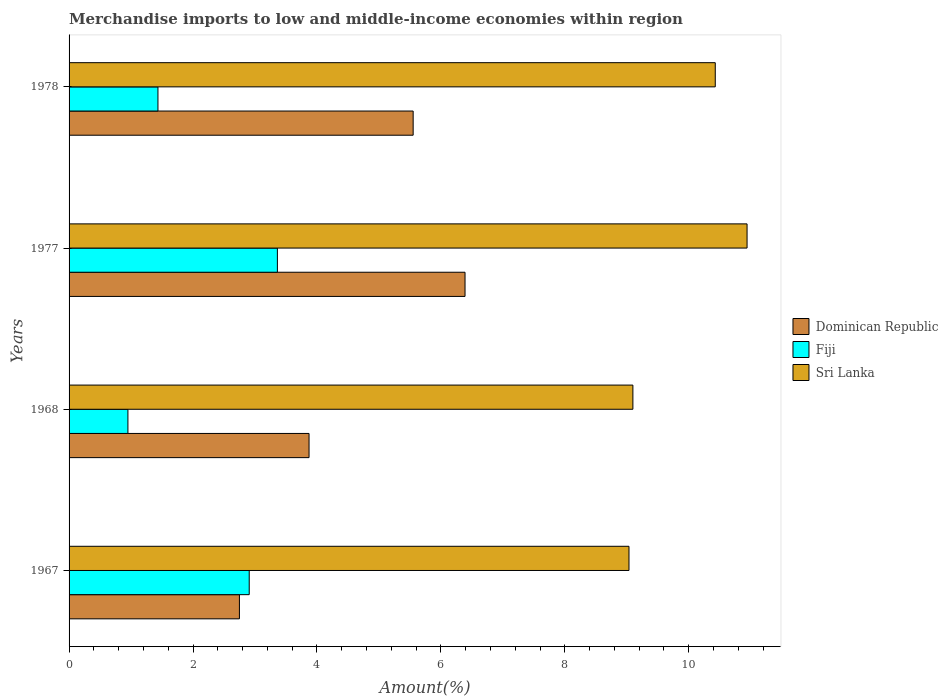How many different coloured bars are there?
Give a very brief answer. 3. How many groups of bars are there?
Your answer should be very brief. 4. How many bars are there on the 4th tick from the top?
Your response must be concise. 3. What is the label of the 1st group of bars from the top?
Offer a very short reply. 1978. What is the percentage of amount earned from merchandise imports in Dominican Republic in 1977?
Your answer should be very brief. 6.39. Across all years, what is the maximum percentage of amount earned from merchandise imports in Sri Lanka?
Offer a very short reply. 10.94. Across all years, what is the minimum percentage of amount earned from merchandise imports in Sri Lanka?
Provide a short and direct response. 9.04. In which year was the percentage of amount earned from merchandise imports in Sri Lanka maximum?
Ensure brevity in your answer.  1977. In which year was the percentage of amount earned from merchandise imports in Sri Lanka minimum?
Offer a very short reply. 1967. What is the total percentage of amount earned from merchandise imports in Sri Lanka in the graph?
Provide a succinct answer. 39.5. What is the difference between the percentage of amount earned from merchandise imports in Sri Lanka in 1967 and that in 1977?
Provide a succinct answer. -1.91. What is the difference between the percentage of amount earned from merchandise imports in Sri Lanka in 1977 and the percentage of amount earned from merchandise imports in Dominican Republic in 1968?
Ensure brevity in your answer.  7.07. What is the average percentage of amount earned from merchandise imports in Sri Lanka per year?
Your response must be concise. 9.88. In the year 1968, what is the difference between the percentage of amount earned from merchandise imports in Sri Lanka and percentage of amount earned from merchandise imports in Dominican Republic?
Your response must be concise. 5.23. What is the ratio of the percentage of amount earned from merchandise imports in Sri Lanka in 1968 to that in 1977?
Your answer should be very brief. 0.83. Is the percentage of amount earned from merchandise imports in Sri Lanka in 1977 less than that in 1978?
Provide a succinct answer. No. Is the difference between the percentage of amount earned from merchandise imports in Sri Lanka in 1968 and 1978 greater than the difference between the percentage of amount earned from merchandise imports in Dominican Republic in 1968 and 1978?
Give a very brief answer. Yes. What is the difference between the highest and the second highest percentage of amount earned from merchandise imports in Sri Lanka?
Give a very brief answer. 0.51. What is the difference between the highest and the lowest percentage of amount earned from merchandise imports in Fiji?
Offer a terse response. 2.41. In how many years, is the percentage of amount earned from merchandise imports in Sri Lanka greater than the average percentage of amount earned from merchandise imports in Sri Lanka taken over all years?
Make the answer very short. 2. What does the 1st bar from the top in 1967 represents?
Ensure brevity in your answer.  Sri Lanka. What does the 2nd bar from the bottom in 1977 represents?
Provide a succinct answer. Fiji. How many bars are there?
Your response must be concise. 12. Are all the bars in the graph horizontal?
Provide a succinct answer. Yes. Does the graph contain any zero values?
Ensure brevity in your answer.  No. How are the legend labels stacked?
Your response must be concise. Vertical. What is the title of the graph?
Keep it short and to the point. Merchandise imports to low and middle-income economies within region. Does "Other small states" appear as one of the legend labels in the graph?
Your answer should be compact. No. What is the label or title of the X-axis?
Ensure brevity in your answer.  Amount(%). What is the Amount(%) of Dominican Republic in 1967?
Keep it short and to the point. 2.75. What is the Amount(%) of Fiji in 1967?
Your answer should be very brief. 2.91. What is the Amount(%) of Sri Lanka in 1967?
Offer a terse response. 9.04. What is the Amount(%) of Dominican Republic in 1968?
Your answer should be very brief. 3.87. What is the Amount(%) in Fiji in 1968?
Make the answer very short. 0.95. What is the Amount(%) in Sri Lanka in 1968?
Make the answer very short. 9.1. What is the Amount(%) of Dominican Republic in 1977?
Your answer should be very brief. 6.39. What is the Amount(%) in Fiji in 1977?
Ensure brevity in your answer.  3.36. What is the Amount(%) in Sri Lanka in 1977?
Your answer should be compact. 10.94. What is the Amount(%) of Dominican Republic in 1978?
Your answer should be very brief. 5.55. What is the Amount(%) in Fiji in 1978?
Your answer should be compact. 1.43. What is the Amount(%) of Sri Lanka in 1978?
Your answer should be very brief. 10.43. Across all years, what is the maximum Amount(%) of Dominican Republic?
Offer a terse response. 6.39. Across all years, what is the maximum Amount(%) in Fiji?
Offer a terse response. 3.36. Across all years, what is the maximum Amount(%) of Sri Lanka?
Offer a very short reply. 10.94. Across all years, what is the minimum Amount(%) in Dominican Republic?
Give a very brief answer. 2.75. Across all years, what is the minimum Amount(%) of Fiji?
Offer a very short reply. 0.95. Across all years, what is the minimum Amount(%) of Sri Lanka?
Provide a succinct answer. 9.04. What is the total Amount(%) in Dominican Republic in the graph?
Your response must be concise. 18.56. What is the total Amount(%) of Fiji in the graph?
Offer a terse response. 8.65. What is the total Amount(%) of Sri Lanka in the graph?
Offer a terse response. 39.5. What is the difference between the Amount(%) in Dominican Republic in 1967 and that in 1968?
Your answer should be very brief. -1.12. What is the difference between the Amount(%) of Fiji in 1967 and that in 1968?
Offer a very short reply. 1.96. What is the difference between the Amount(%) in Sri Lanka in 1967 and that in 1968?
Your response must be concise. -0.06. What is the difference between the Amount(%) of Dominican Republic in 1967 and that in 1977?
Offer a terse response. -3.64. What is the difference between the Amount(%) in Fiji in 1967 and that in 1977?
Make the answer very short. -0.45. What is the difference between the Amount(%) in Sri Lanka in 1967 and that in 1977?
Make the answer very short. -1.91. What is the difference between the Amount(%) of Dominican Republic in 1967 and that in 1978?
Offer a very short reply. -2.8. What is the difference between the Amount(%) in Fiji in 1967 and that in 1978?
Offer a terse response. 1.47. What is the difference between the Amount(%) in Sri Lanka in 1967 and that in 1978?
Provide a short and direct response. -1.39. What is the difference between the Amount(%) of Dominican Republic in 1968 and that in 1977?
Your answer should be compact. -2.52. What is the difference between the Amount(%) of Fiji in 1968 and that in 1977?
Ensure brevity in your answer.  -2.41. What is the difference between the Amount(%) in Sri Lanka in 1968 and that in 1977?
Ensure brevity in your answer.  -1.84. What is the difference between the Amount(%) of Dominican Republic in 1968 and that in 1978?
Your answer should be compact. -1.68. What is the difference between the Amount(%) in Fiji in 1968 and that in 1978?
Keep it short and to the point. -0.48. What is the difference between the Amount(%) in Sri Lanka in 1968 and that in 1978?
Keep it short and to the point. -1.33. What is the difference between the Amount(%) in Dominican Republic in 1977 and that in 1978?
Give a very brief answer. 0.84. What is the difference between the Amount(%) of Fiji in 1977 and that in 1978?
Offer a very short reply. 1.93. What is the difference between the Amount(%) of Sri Lanka in 1977 and that in 1978?
Give a very brief answer. 0.51. What is the difference between the Amount(%) in Dominican Republic in 1967 and the Amount(%) in Fiji in 1968?
Offer a terse response. 1.8. What is the difference between the Amount(%) of Dominican Republic in 1967 and the Amount(%) of Sri Lanka in 1968?
Ensure brevity in your answer.  -6.35. What is the difference between the Amount(%) in Fiji in 1967 and the Amount(%) in Sri Lanka in 1968?
Ensure brevity in your answer.  -6.19. What is the difference between the Amount(%) of Dominican Republic in 1967 and the Amount(%) of Fiji in 1977?
Provide a succinct answer. -0.61. What is the difference between the Amount(%) in Dominican Republic in 1967 and the Amount(%) in Sri Lanka in 1977?
Offer a terse response. -8.19. What is the difference between the Amount(%) of Fiji in 1967 and the Amount(%) of Sri Lanka in 1977?
Provide a short and direct response. -8.03. What is the difference between the Amount(%) of Dominican Republic in 1967 and the Amount(%) of Fiji in 1978?
Keep it short and to the point. 1.31. What is the difference between the Amount(%) in Dominican Republic in 1967 and the Amount(%) in Sri Lanka in 1978?
Ensure brevity in your answer.  -7.68. What is the difference between the Amount(%) of Fiji in 1967 and the Amount(%) of Sri Lanka in 1978?
Provide a succinct answer. -7.52. What is the difference between the Amount(%) of Dominican Republic in 1968 and the Amount(%) of Fiji in 1977?
Provide a short and direct response. 0.51. What is the difference between the Amount(%) in Dominican Republic in 1968 and the Amount(%) in Sri Lanka in 1977?
Keep it short and to the point. -7.07. What is the difference between the Amount(%) of Fiji in 1968 and the Amount(%) of Sri Lanka in 1977?
Offer a terse response. -9.99. What is the difference between the Amount(%) in Dominican Republic in 1968 and the Amount(%) in Fiji in 1978?
Give a very brief answer. 2.44. What is the difference between the Amount(%) in Dominican Republic in 1968 and the Amount(%) in Sri Lanka in 1978?
Provide a succinct answer. -6.56. What is the difference between the Amount(%) in Fiji in 1968 and the Amount(%) in Sri Lanka in 1978?
Your response must be concise. -9.48. What is the difference between the Amount(%) of Dominican Republic in 1977 and the Amount(%) of Fiji in 1978?
Make the answer very short. 4.96. What is the difference between the Amount(%) in Dominican Republic in 1977 and the Amount(%) in Sri Lanka in 1978?
Offer a very short reply. -4.04. What is the difference between the Amount(%) of Fiji in 1977 and the Amount(%) of Sri Lanka in 1978?
Ensure brevity in your answer.  -7.07. What is the average Amount(%) of Dominican Republic per year?
Make the answer very short. 4.64. What is the average Amount(%) of Fiji per year?
Your answer should be very brief. 2.16. What is the average Amount(%) in Sri Lanka per year?
Ensure brevity in your answer.  9.88. In the year 1967, what is the difference between the Amount(%) of Dominican Republic and Amount(%) of Fiji?
Your response must be concise. -0.16. In the year 1967, what is the difference between the Amount(%) in Dominican Republic and Amount(%) in Sri Lanka?
Offer a very short reply. -6.29. In the year 1967, what is the difference between the Amount(%) of Fiji and Amount(%) of Sri Lanka?
Your answer should be very brief. -6.13. In the year 1968, what is the difference between the Amount(%) in Dominican Republic and Amount(%) in Fiji?
Your answer should be very brief. 2.92. In the year 1968, what is the difference between the Amount(%) of Dominican Republic and Amount(%) of Sri Lanka?
Keep it short and to the point. -5.23. In the year 1968, what is the difference between the Amount(%) in Fiji and Amount(%) in Sri Lanka?
Offer a very short reply. -8.15. In the year 1977, what is the difference between the Amount(%) of Dominican Republic and Amount(%) of Fiji?
Your response must be concise. 3.03. In the year 1977, what is the difference between the Amount(%) of Dominican Republic and Amount(%) of Sri Lanka?
Keep it short and to the point. -4.55. In the year 1977, what is the difference between the Amount(%) of Fiji and Amount(%) of Sri Lanka?
Provide a succinct answer. -7.58. In the year 1978, what is the difference between the Amount(%) of Dominican Republic and Amount(%) of Fiji?
Provide a succinct answer. 4.12. In the year 1978, what is the difference between the Amount(%) in Dominican Republic and Amount(%) in Sri Lanka?
Offer a very short reply. -4.88. In the year 1978, what is the difference between the Amount(%) in Fiji and Amount(%) in Sri Lanka?
Ensure brevity in your answer.  -8.99. What is the ratio of the Amount(%) in Dominican Republic in 1967 to that in 1968?
Provide a succinct answer. 0.71. What is the ratio of the Amount(%) of Fiji in 1967 to that in 1968?
Make the answer very short. 3.06. What is the ratio of the Amount(%) in Sri Lanka in 1967 to that in 1968?
Your answer should be very brief. 0.99. What is the ratio of the Amount(%) in Dominican Republic in 1967 to that in 1977?
Provide a succinct answer. 0.43. What is the ratio of the Amount(%) of Fiji in 1967 to that in 1977?
Provide a succinct answer. 0.86. What is the ratio of the Amount(%) of Sri Lanka in 1967 to that in 1977?
Your answer should be very brief. 0.83. What is the ratio of the Amount(%) in Dominican Republic in 1967 to that in 1978?
Ensure brevity in your answer.  0.5. What is the ratio of the Amount(%) of Fiji in 1967 to that in 1978?
Provide a short and direct response. 2.03. What is the ratio of the Amount(%) of Sri Lanka in 1967 to that in 1978?
Give a very brief answer. 0.87. What is the ratio of the Amount(%) in Dominican Republic in 1968 to that in 1977?
Keep it short and to the point. 0.61. What is the ratio of the Amount(%) of Fiji in 1968 to that in 1977?
Offer a terse response. 0.28. What is the ratio of the Amount(%) in Sri Lanka in 1968 to that in 1977?
Provide a succinct answer. 0.83. What is the ratio of the Amount(%) of Dominican Republic in 1968 to that in 1978?
Make the answer very short. 0.7. What is the ratio of the Amount(%) in Fiji in 1968 to that in 1978?
Keep it short and to the point. 0.66. What is the ratio of the Amount(%) in Sri Lanka in 1968 to that in 1978?
Give a very brief answer. 0.87. What is the ratio of the Amount(%) in Dominican Republic in 1977 to that in 1978?
Ensure brevity in your answer.  1.15. What is the ratio of the Amount(%) of Fiji in 1977 to that in 1978?
Your answer should be very brief. 2.34. What is the ratio of the Amount(%) of Sri Lanka in 1977 to that in 1978?
Your answer should be compact. 1.05. What is the difference between the highest and the second highest Amount(%) in Dominican Republic?
Make the answer very short. 0.84. What is the difference between the highest and the second highest Amount(%) of Fiji?
Your answer should be very brief. 0.45. What is the difference between the highest and the second highest Amount(%) of Sri Lanka?
Your response must be concise. 0.51. What is the difference between the highest and the lowest Amount(%) of Dominican Republic?
Your answer should be very brief. 3.64. What is the difference between the highest and the lowest Amount(%) in Fiji?
Your response must be concise. 2.41. What is the difference between the highest and the lowest Amount(%) of Sri Lanka?
Your response must be concise. 1.91. 